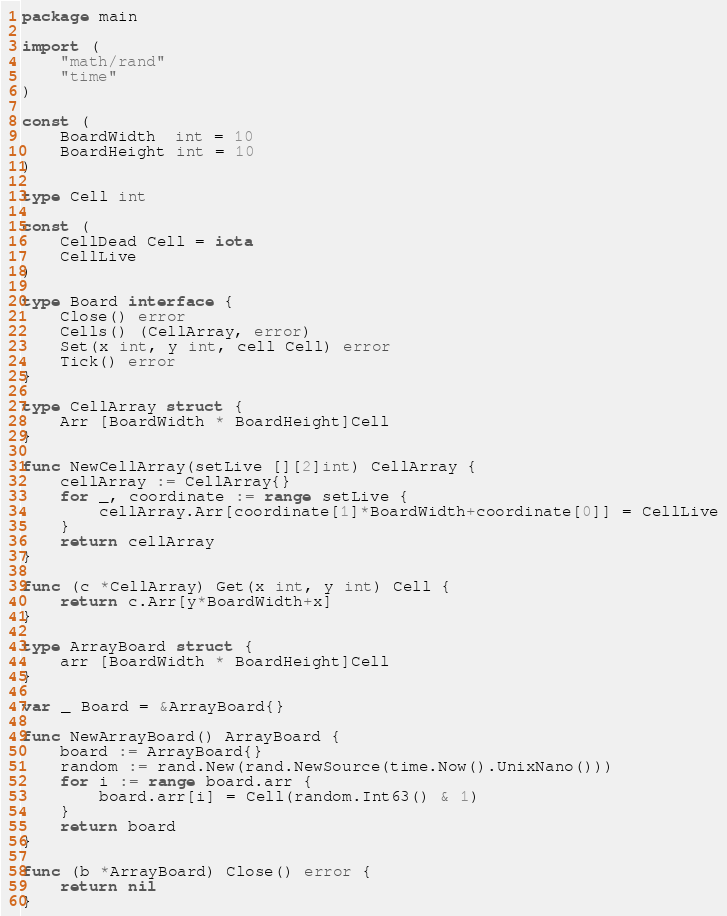Convert code to text. <code><loc_0><loc_0><loc_500><loc_500><_Go_>package main

import (
	"math/rand"
	"time"
)

const (
	BoardWidth  int = 10
	BoardHeight int = 10
)

type Cell int

const (
	CellDead Cell = iota
	CellLive
)

type Board interface {
	Close() error
	Cells() (CellArray, error)
	Set(x int, y int, cell Cell) error
	Tick() error
}

type CellArray struct {
	Arr [BoardWidth * BoardHeight]Cell
}

func NewCellArray(setLive [][2]int) CellArray {
	cellArray := CellArray{}
	for _, coordinate := range setLive {
		cellArray.Arr[coordinate[1]*BoardWidth+coordinate[0]] = CellLive
	}
	return cellArray
}

func (c *CellArray) Get(x int, y int) Cell {
	return c.Arr[y*BoardWidth+x]
}

type ArrayBoard struct {
	arr [BoardWidth * BoardHeight]Cell
}

var _ Board = &ArrayBoard{}

func NewArrayBoard() ArrayBoard {
	board := ArrayBoard{}
	random := rand.New(rand.NewSource(time.Now().UnixNano()))
	for i := range board.arr {
		board.arr[i] = Cell(random.Int63() & 1)
	}
	return board
}

func (b *ArrayBoard) Close() error {
	return nil
}
</code> 